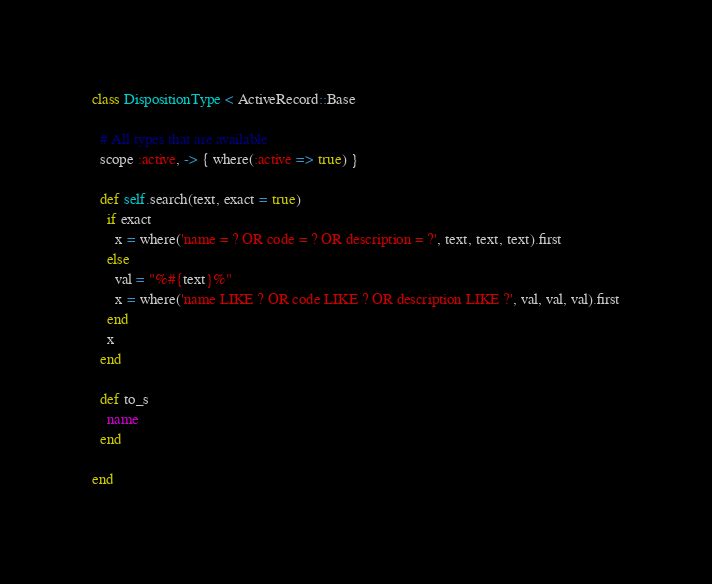Convert code to text. <code><loc_0><loc_0><loc_500><loc_500><_Ruby_>class DispositionType < ActiveRecord::Base

  # All types that are available
  scope :active, -> { where(:active => true) }

  def self.search(text, exact = true)
    if exact
      x = where('name = ? OR code = ? OR description = ?', text, text, text).first
    else
      val = "%#{text}%"
      x = where('name LIKE ? OR code LIKE ? OR description LIKE ?', val, val, val).first
    end
    x
  end

  def to_s
    name
  end

end
</code> 